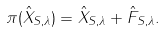Convert formula to latex. <formula><loc_0><loc_0><loc_500><loc_500>\pi ( \hat { X } _ { S , \lambda } ) = \hat { X } _ { S , \lambda } + \hat { F } _ { S , \lambda } .</formula> 